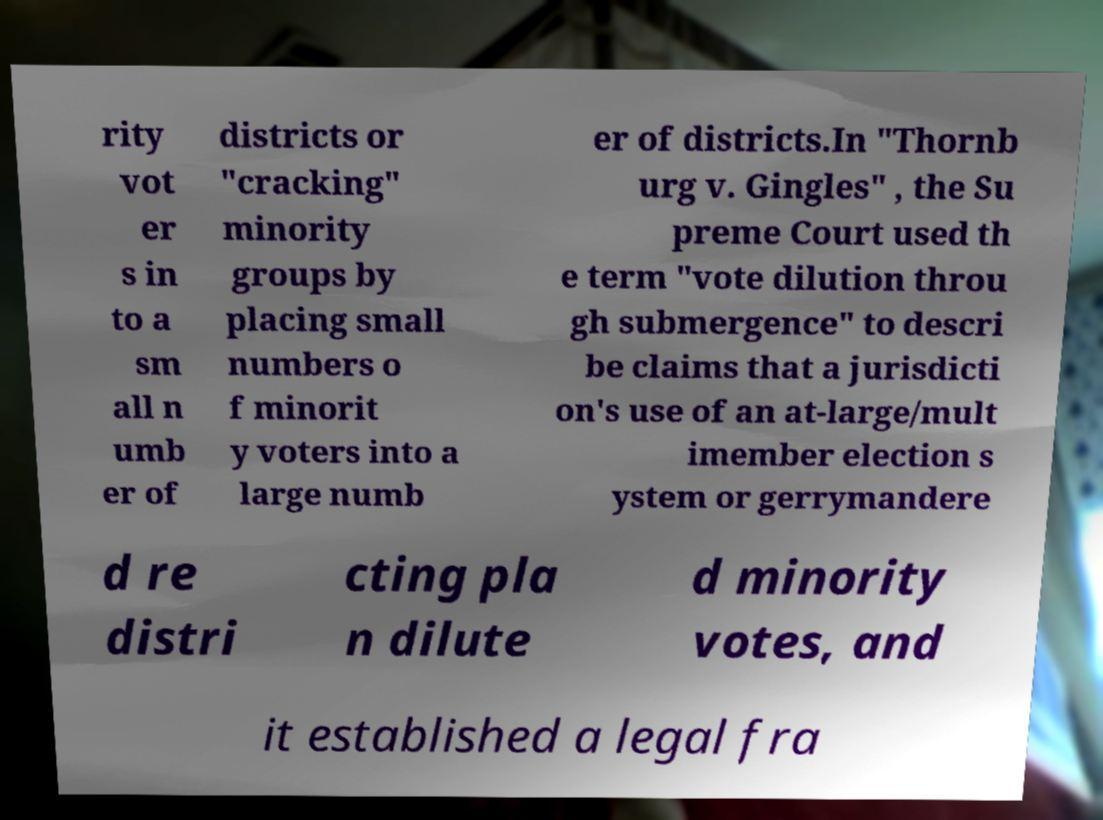Could you extract and type out the text from this image? rity vot er s in to a sm all n umb er of districts or "cracking" minority groups by placing small numbers o f minorit y voters into a large numb er of districts.In "Thornb urg v. Gingles" , the Su preme Court used th e term "vote dilution throu gh submergence" to descri be claims that a jurisdicti on's use of an at-large/mult imember election s ystem or gerrymandere d re distri cting pla n dilute d minority votes, and it established a legal fra 